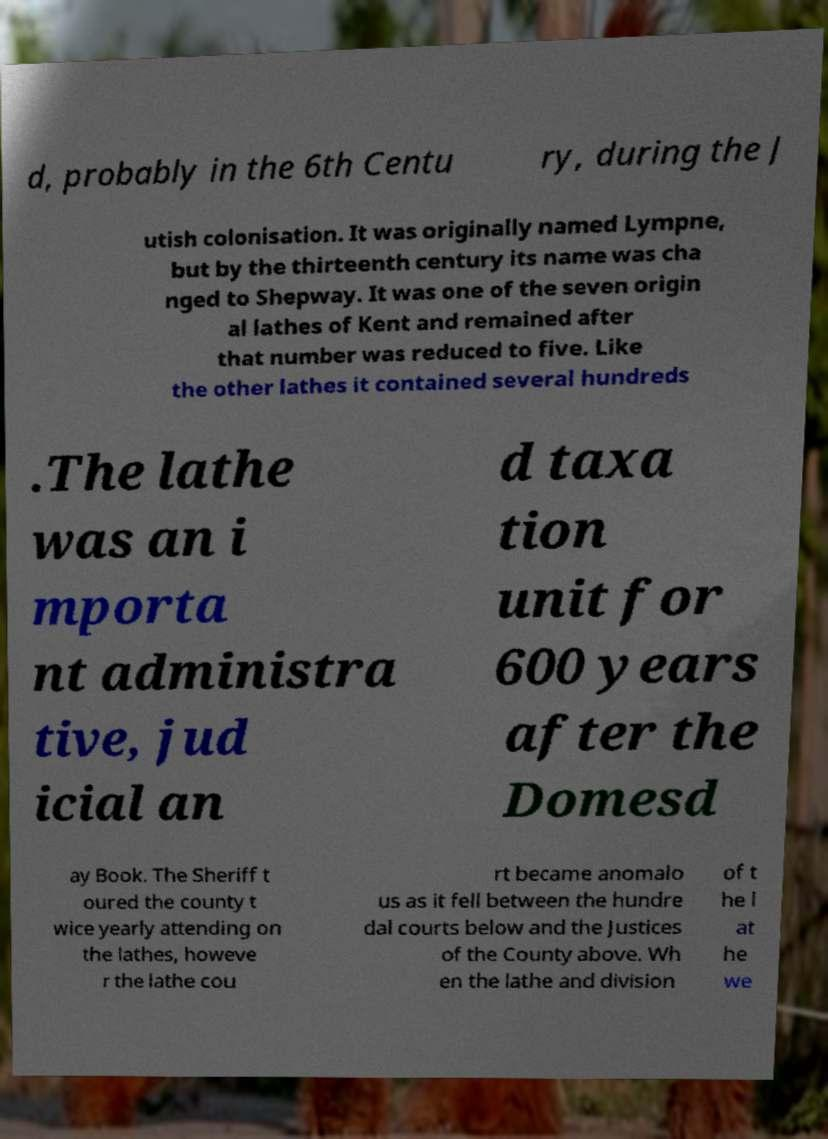Can you read and provide the text displayed in the image?This photo seems to have some interesting text. Can you extract and type it out for me? d, probably in the 6th Centu ry, during the J utish colonisation. It was originally named Lympne, but by the thirteenth century its name was cha nged to Shepway. It was one of the seven origin al lathes of Kent and remained after that number was reduced to five. Like the other lathes it contained several hundreds .The lathe was an i mporta nt administra tive, jud icial an d taxa tion unit for 600 years after the Domesd ay Book. The Sheriff t oured the county t wice yearly attending on the lathes, howeve r the lathe cou rt became anomalo us as it fell between the hundre dal courts below and the Justices of the County above. Wh en the lathe and division of t he l at he we 